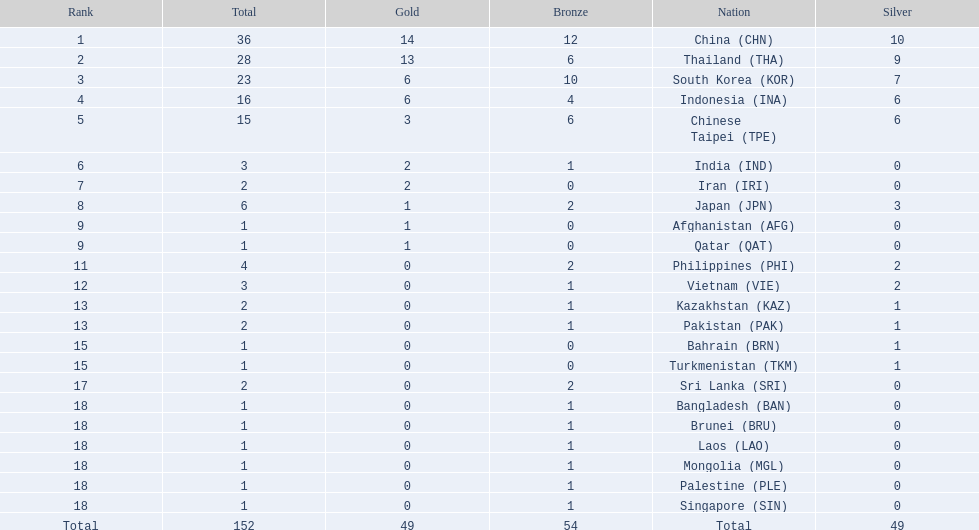Help me parse the entirety of this table. {'header': ['Rank', 'Total', 'Gold', 'Bronze', 'Nation', 'Silver'], 'rows': [['1', '36', '14', '12', 'China\xa0(CHN)', '10'], ['2', '28', '13', '6', 'Thailand\xa0(THA)', '9'], ['3', '23', '6', '10', 'South Korea\xa0(KOR)', '7'], ['4', '16', '6', '4', 'Indonesia\xa0(INA)', '6'], ['5', '15', '3', '6', 'Chinese Taipei\xa0(TPE)', '6'], ['6', '3', '2', '1', 'India\xa0(IND)', '0'], ['7', '2', '2', '0', 'Iran\xa0(IRI)', '0'], ['8', '6', '1', '2', 'Japan\xa0(JPN)', '3'], ['9', '1', '1', '0', 'Afghanistan\xa0(AFG)', '0'], ['9', '1', '1', '0', 'Qatar\xa0(QAT)', '0'], ['11', '4', '0', '2', 'Philippines\xa0(PHI)', '2'], ['12', '3', '0', '1', 'Vietnam\xa0(VIE)', '2'], ['13', '2', '0', '1', 'Kazakhstan\xa0(KAZ)', '1'], ['13', '2', '0', '1', 'Pakistan\xa0(PAK)', '1'], ['15', '1', '0', '0', 'Bahrain\xa0(BRN)', '1'], ['15', '1', '0', '0', 'Turkmenistan\xa0(TKM)', '1'], ['17', '2', '0', '2', 'Sri Lanka\xa0(SRI)', '0'], ['18', '1', '0', '1', 'Bangladesh\xa0(BAN)', '0'], ['18', '1', '0', '1', 'Brunei\xa0(BRU)', '0'], ['18', '1', '0', '1', 'Laos\xa0(LAO)', '0'], ['18', '1', '0', '1', 'Mongolia\xa0(MGL)', '0'], ['18', '1', '0', '1', 'Palestine\xa0(PLE)', '0'], ['18', '1', '0', '1', 'Singapore\xa0(SIN)', '0'], ['Total', '152', '49', '54', 'Total', '49']]} How many nations won no silver medals at all? 11. 